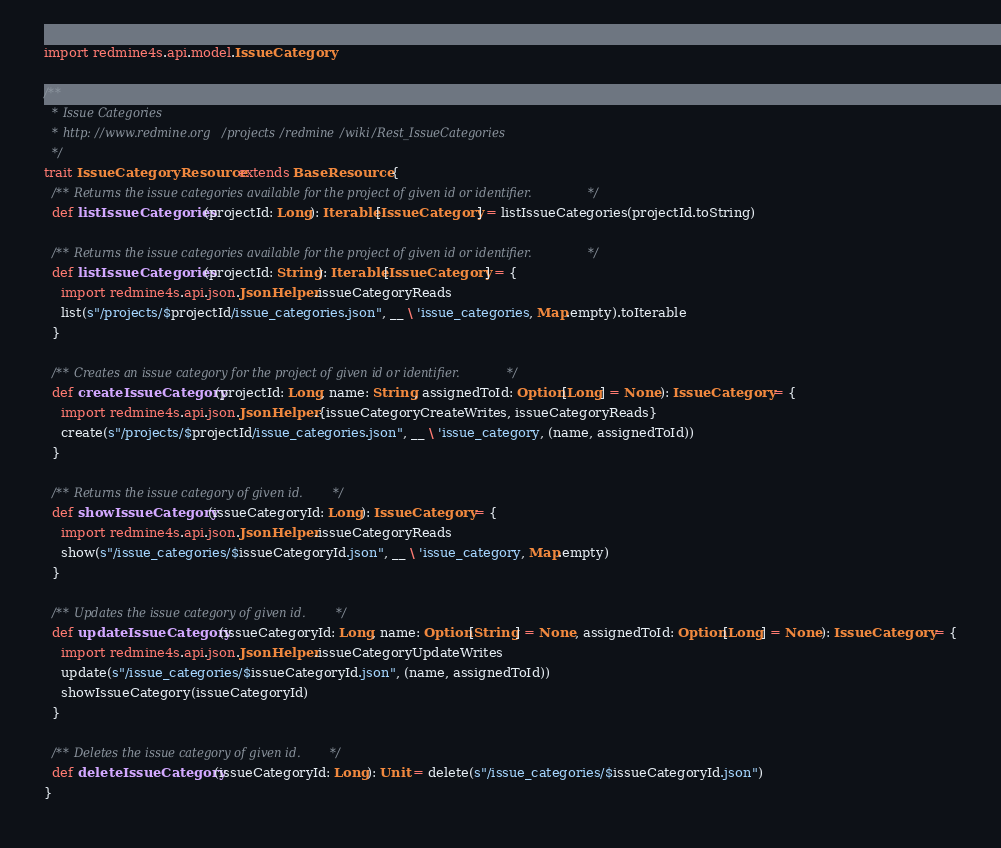Convert code to text. <code><loc_0><loc_0><loc_500><loc_500><_Scala_>import redmine4s.api.model.IssueCategory

/**
  * Issue Categories
  * http://www.redmine.org/projects/redmine/wiki/Rest_IssueCategories
  */
trait IssueCategoryResource extends BaseResource {
  /** Returns the issue categories available for the project of given id or identifier. */
  def listIssueCategories(projectId: Long): Iterable[IssueCategory] = listIssueCategories(projectId.toString)

  /** Returns the issue categories available for the project of given id or identifier. */
  def listIssueCategories(projectId: String): Iterable[IssueCategory] = {
    import redmine4s.api.json.JsonHelper.issueCategoryReads
    list(s"/projects/$projectId/issue_categories.json", __ \ 'issue_categories, Map.empty).toIterable
  }

  /** Creates an issue category for the project of given id or identifier. */
  def createIssueCategory(projectId: Long, name: String, assignedToId: Option[Long] = None): IssueCategory = {
    import redmine4s.api.json.JsonHelper.{issueCategoryCreateWrites, issueCategoryReads}
    create(s"/projects/$projectId/issue_categories.json", __ \ 'issue_category, (name, assignedToId))
  }

  /** Returns the issue category of given id. */
  def showIssueCategory(issueCategoryId: Long): IssueCategory = {
    import redmine4s.api.json.JsonHelper.issueCategoryReads
    show(s"/issue_categories/$issueCategoryId.json", __ \ 'issue_category, Map.empty)
  }

  /** Updates the issue category of given id. */
  def updateIssueCategory(issueCategoryId: Long, name: Option[String] = None, assignedToId: Option[Long] = None): IssueCategory = {
    import redmine4s.api.json.JsonHelper.issueCategoryUpdateWrites
    update(s"/issue_categories/$issueCategoryId.json", (name, assignedToId))
    showIssueCategory(issueCategoryId)
  }

  /** Deletes the issue category of given id. */
  def deleteIssueCategory(issueCategoryId: Long): Unit = delete(s"/issue_categories/$issueCategoryId.json")
}
</code> 